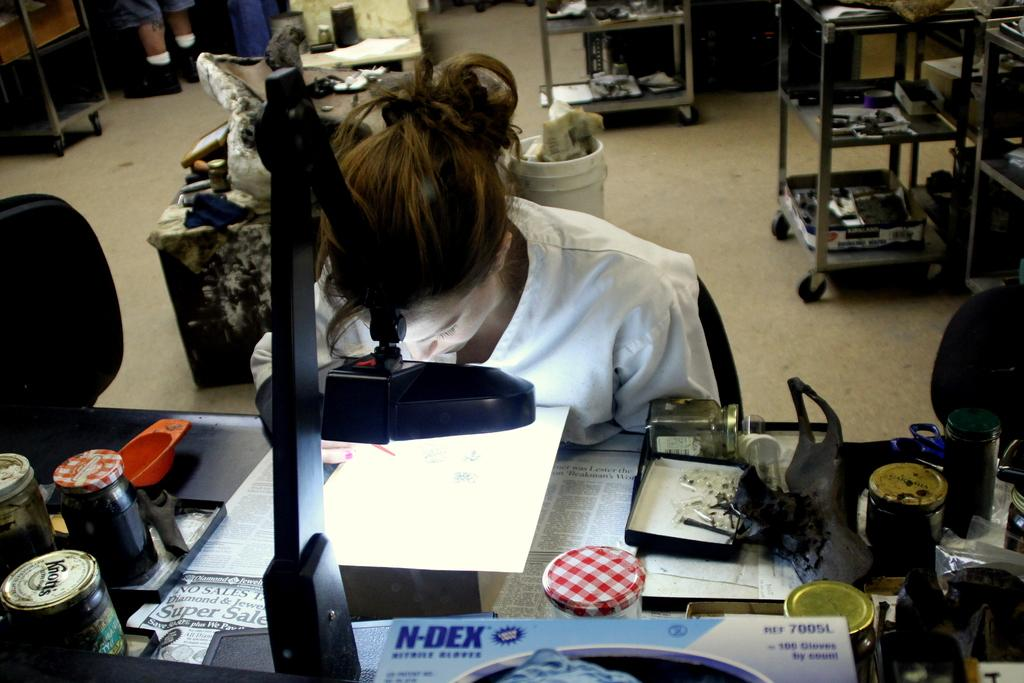<image>
Describe the image concisely. A woman works under a bright light, with an N-DEX box nearby. 